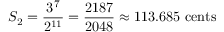Convert formula to latex. <formula><loc_0><loc_0><loc_500><loc_500>S _ { 2 } = { \frac { 3 ^ { 7 } } { 2 ^ { 1 1 } } } = { \frac { 2 1 8 7 } { 2 0 4 8 } } \approx 1 1 3 . 6 8 5 \ { c e n t s }</formula> 